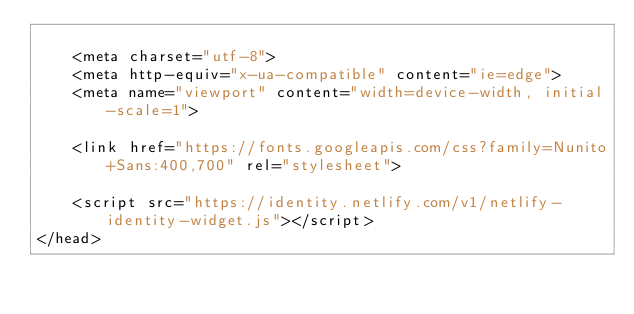<code> <loc_0><loc_0><loc_500><loc_500><_HTML_>
	<meta charset="utf-8">
	<meta http-equiv="x-ua-compatible" content="ie=edge">
	<meta name="viewport" content="width=device-width, initial-scale=1">

	<link href="https://fonts.googleapis.com/css?family=Nunito+Sans:400,700" rel="stylesheet">

	<script src="https://identity.netlify.com/v1/netlify-identity-widget.js"></script>
</head>
</code> 